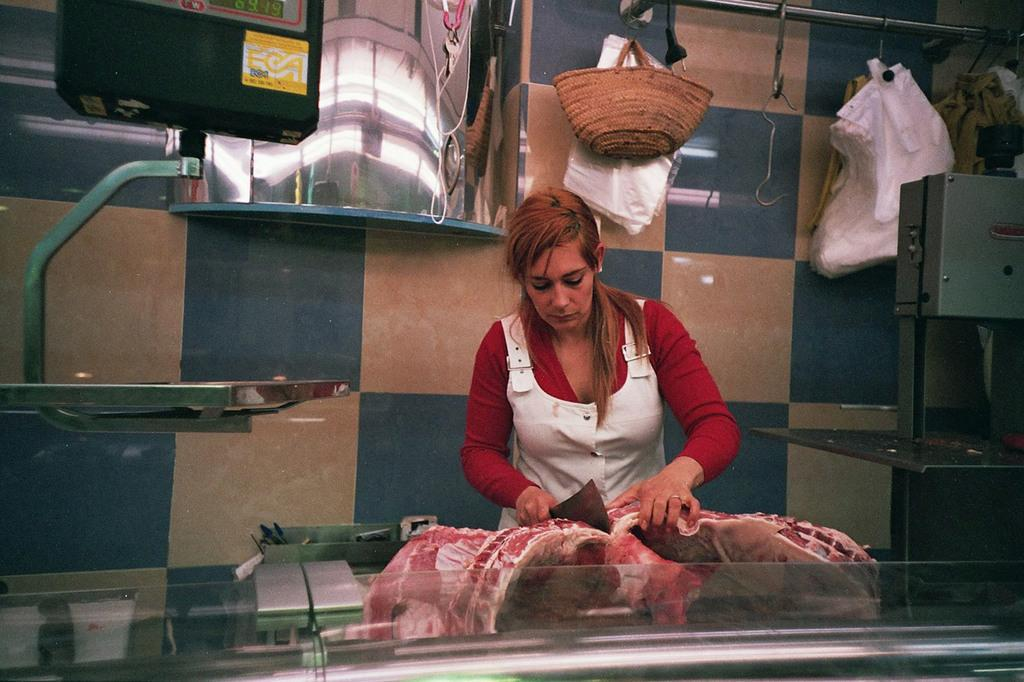Who is the main subject in the image? There is a woman in the center of the image. What is the woman doing in the image? The woman is cutting meat. What can be seen in the background of the image? There is a bag, covers, hangers, a mirror, and a wall in the background of the image. What type of ship can be seen sailing in the background of the image? There is no ship present in the image; it features a woman cutting meat and various items in the background. How does the plough help with the woman's task in the image? There is no plough present in the image, and it is not related to the woman cutting meat. 